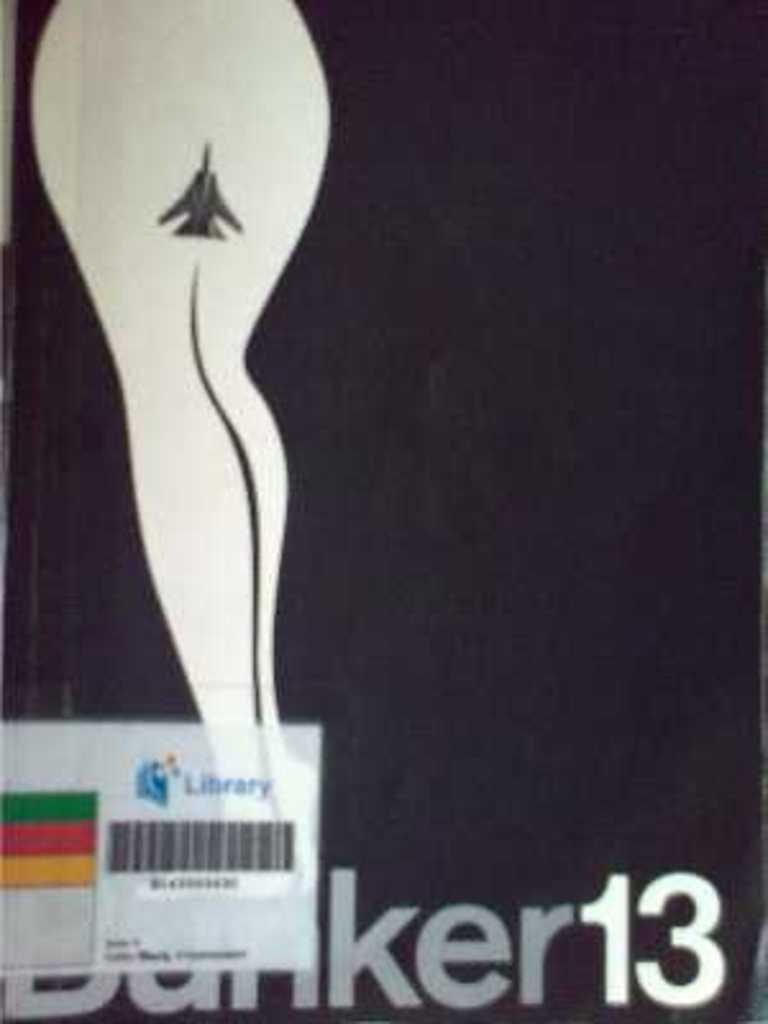What type of place is this book from?
Provide a succinct answer. Library. What number is on the book?
Give a very brief answer. 13. 